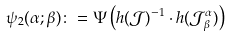Convert formula to latex. <formula><loc_0><loc_0><loc_500><loc_500>\psi _ { 2 } ( \alpha ; \beta ) \colon = \Psi \left ( h ( \mathcal { J } ) ^ { - 1 } \cdot h ( \mathcal { J } _ { \beta } ^ { \alpha } ) \right )</formula> 